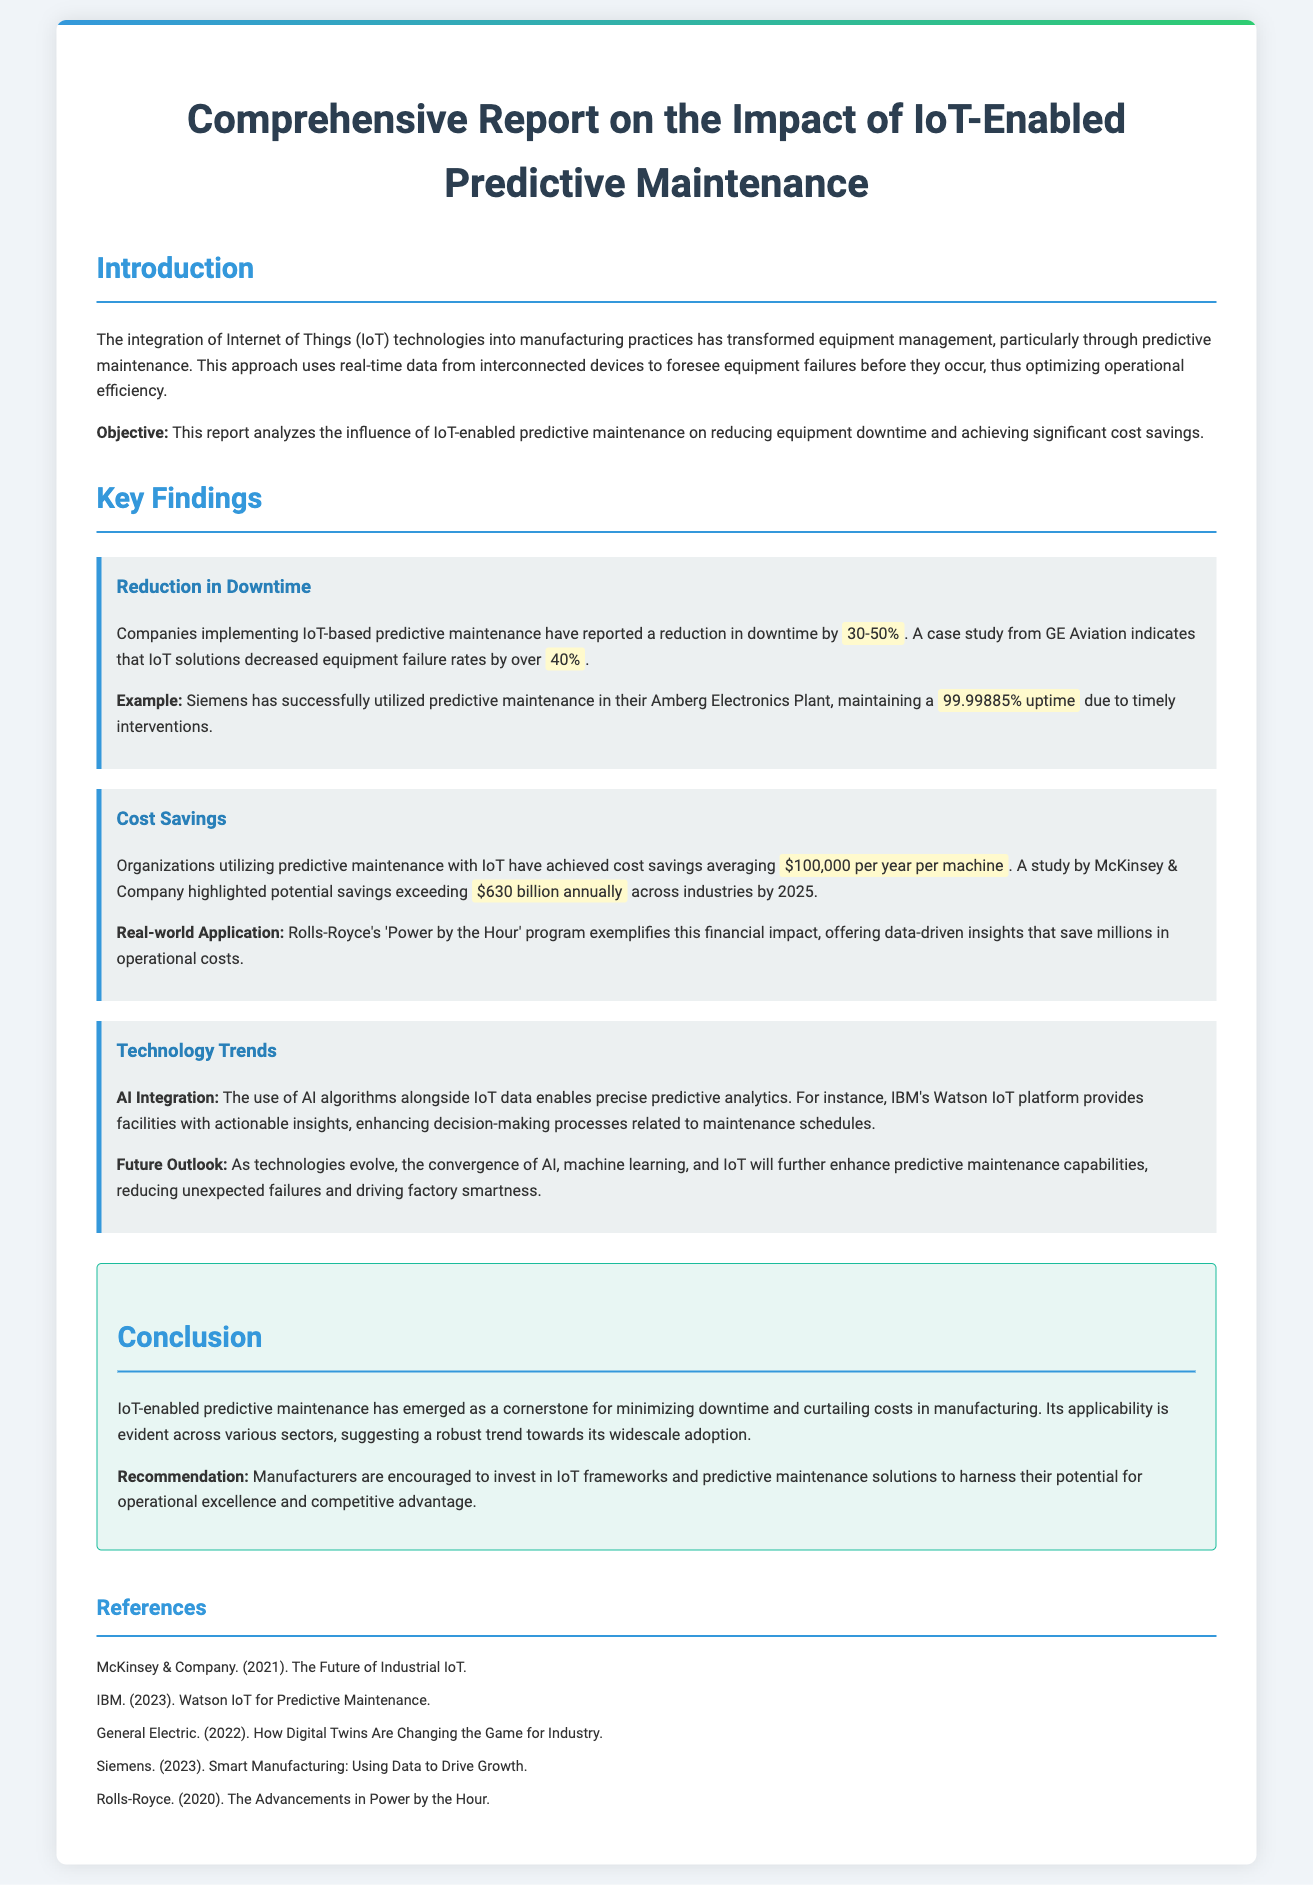What is the percentage reduction in downtime reported by companies? Companies implementing IoT-based predictive maintenance have reported a reduction in downtime by 30-50%.
Answer: 30-50% Which company's case study indicates a 40% decrease in equipment failure rates? A case study from GE Aviation indicates that IoT solutions decreased equipment failure rates by over 40%.
Answer: GE Aviation What is the average annual cost saving for organizations utilizing predictive maintenance? Organizations utilizing predictive maintenance with IoT have achieved cost savings averaging $100,000 per year per machine.
Answer: $100,000 What is the expected annual savings across industries by 2025, as highlighted by a McKinsey study? A study by McKinsey & Company highlighted potential savings exceeding $630 billion annually across industries by 2025.
Answer: $630 billion How much uptime does Siemens maintain due to timely interventions? Siemens has successfully utilized predictive maintenance in their Amberg Electronics Plant, maintaining a 99.99885% uptime due to timely interventions.
Answer: 99.99885% What technology is integrated alongside IoT data for predictive analytics? The use of AI algorithms alongside IoT data enables precise predictive analytics.
Answer: AI algorithms What is the recommendation for manufacturers regarding IoT frameworks? Manufacturers are encouraged to invest in IoT frameworks and predictive maintenance solutions.
Answer: Invest in IoT frameworks What platform does IBM provide for actionable insights related to maintenance schedules? IBM's Watson IoT platform provides facilities with actionable insights, enhancing decision-making processes related to maintenance schedules.
Answer: Watson IoT platform 